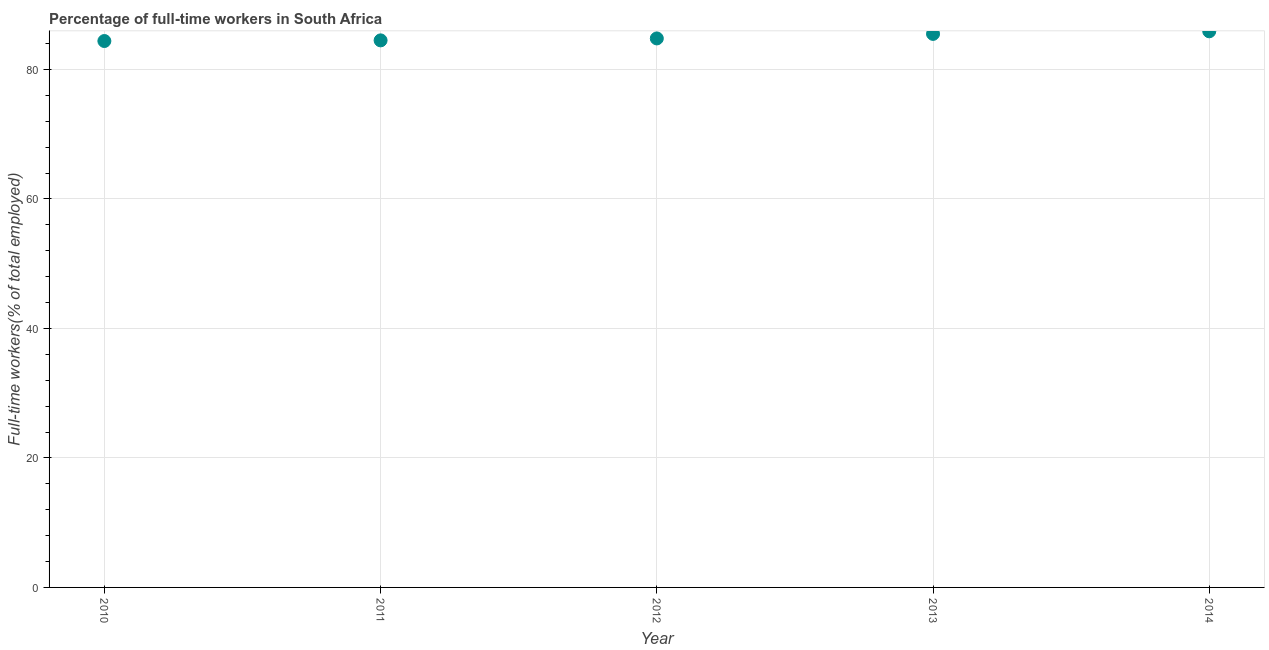What is the percentage of full-time workers in 2014?
Provide a short and direct response. 85.9. Across all years, what is the maximum percentage of full-time workers?
Your answer should be very brief. 85.9. Across all years, what is the minimum percentage of full-time workers?
Provide a short and direct response. 84.4. In which year was the percentage of full-time workers maximum?
Provide a succinct answer. 2014. What is the sum of the percentage of full-time workers?
Your response must be concise. 425.1. What is the difference between the percentage of full-time workers in 2010 and 2012?
Provide a succinct answer. -0.4. What is the average percentage of full-time workers per year?
Keep it short and to the point. 85.02. What is the median percentage of full-time workers?
Provide a succinct answer. 84.8. In how many years, is the percentage of full-time workers greater than 4 %?
Keep it short and to the point. 5. Do a majority of the years between 2011 and 2014 (inclusive) have percentage of full-time workers greater than 36 %?
Offer a very short reply. Yes. What is the ratio of the percentage of full-time workers in 2010 to that in 2014?
Make the answer very short. 0.98. Is the percentage of full-time workers in 2011 less than that in 2013?
Your answer should be very brief. Yes. Is the difference between the percentage of full-time workers in 2010 and 2011 greater than the difference between any two years?
Keep it short and to the point. No. What is the difference between the highest and the second highest percentage of full-time workers?
Make the answer very short. 0.4. How many years are there in the graph?
Keep it short and to the point. 5. What is the difference between two consecutive major ticks on the Y-axis?
Ensure brevity in your answer.  20. Are the values on the major ticks of Y-axis written in scientific E-notation?
Keep it short and to the point. No. Does the graph contain any zero values?
Make the answer very short. No. What is the title of the graph?
Ensure brevity in your answer.  Percentage of full-time workers in South Africa. What is the label or title of the Y-axis?
Give a very brief answer. Full-time workers(% of total employed). What is the Full-time workers(% of total employed) in 2010?
Your response must be concise. 84.4. What is the Full-time workers(% of total employed) in 2011?
Offer a terse response. 84.5. What is the Full-time workers(% of total employed) in 2012?
Keep it short and to the point. 84.8. What is the Full-time workers(% of total employed) in 2013?
Make the answer very short. 85.5. What is the Full-time workers(% of total employed) in 2014?
Make the answer very short. 85.9. What is the difference between the Full-time workers(% of total employed) in 2010 and 2012?
Make the answer very short. -0.4. What is the difference between the Full-time workers(% of total employed) in 2010 and 2013?
Offer a terse response. -1.1. What is the difference between the Full-time workers(% of total employed) in 2010 and 2014?
Provide a succinct answer. -1.5. What is the difference between the Full-time workers(% of total employed) in 2012 and 2013?
Ensure brevity in your answer.  -0.7. What is the difference between the Full-time workers(% of total employed) in 2013 and 2014?
Your answer should be compact. -0.4. What is the ratio of the Full-time workers(% of total employed) in 2010 to that in 2011?
Provide a short and direct response. 1. What is the ratio of the Full-time workers(% of total employed) in 2010 to that in 2013?
Your answer should be very brief. 0.99. What is the ratio of the Full-time workers(% of total employed) in 2012 to that in 2013?
Offer a very short reply. 0.99. What is the ratio of the Full-time workers(% of total employed) in 2013 to that in 2014?
Provide a short and direct response. 0.99. 